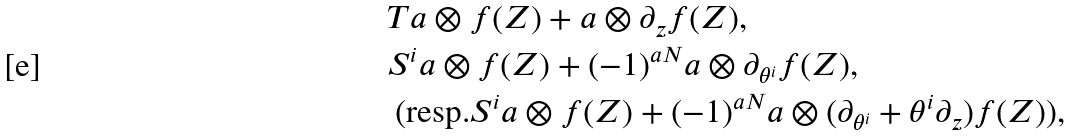<formula> <loc_0><loc_0><loc_500><loc_500>& T a \otimes f ( Z ) + a \otimes \partial _ { z } f ( Z ) , \\ & S ^ { i } a \otimes f ( Z ) + ( - 1 ) ^ { a N } a \otimes \partial _ { \theta ^ { i } } f ( Z ) , \\ & \text { (resp.} S ^ { i } a \otimes f ( Z ) + ( - 1 ) ^ { a N } a \otimes ( \partial _ { \theta ^ { i } } + \theta ^ { i } \partial _ { z } ) f ( Z ) \text {)} ,</formula> 